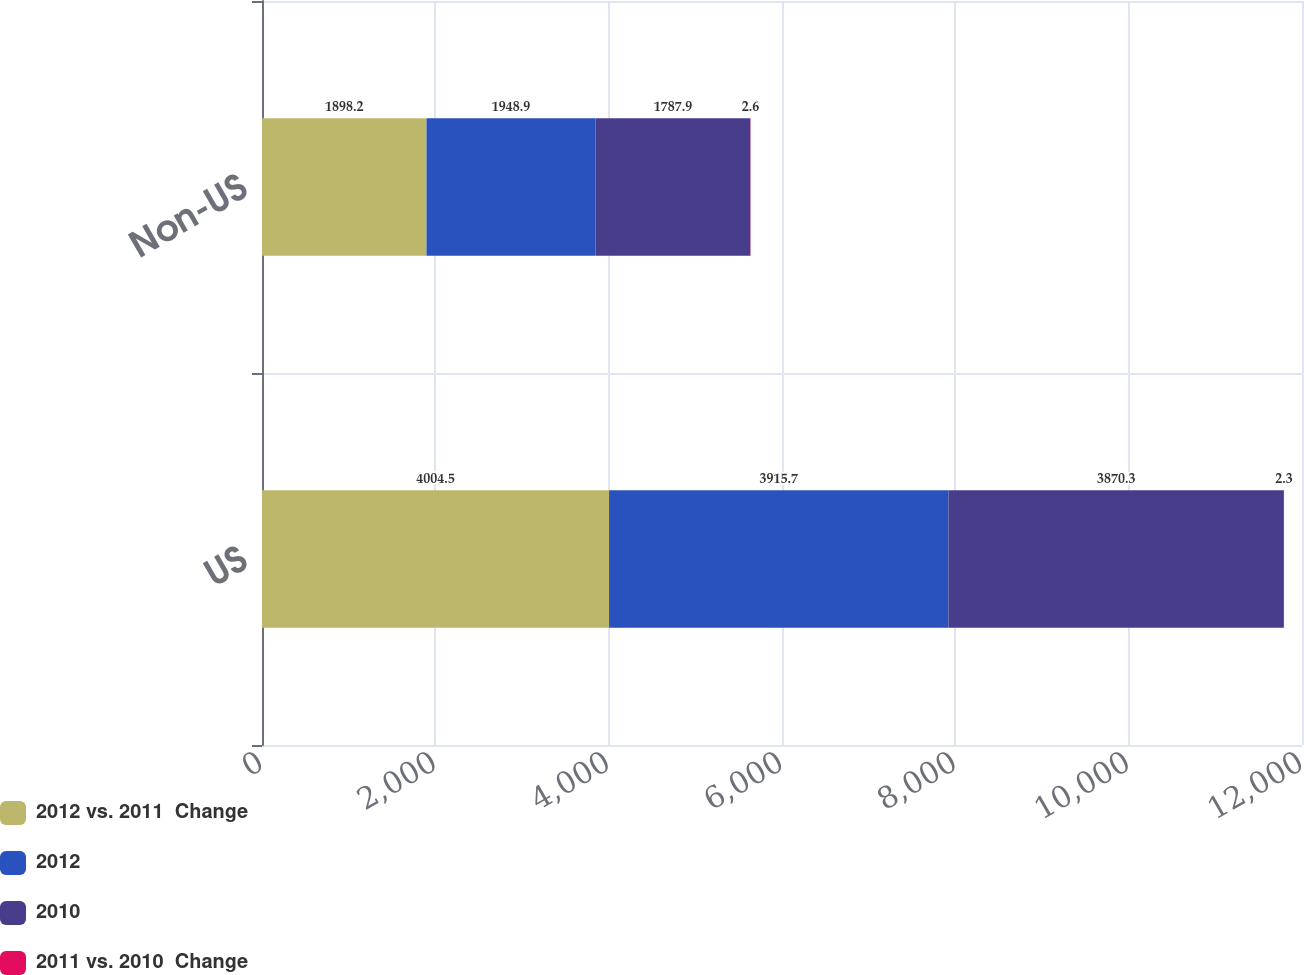Convert chart. <chart><loc_0><loc_0><loc_500><loc_500><stacked_bar_chart><ecel><fcel>US<fcel>Non-US<nl><fcel>2012 vs. 2011  Change<fcel>4004.5<fcel>1898.2<nl><fcel>2012<fcel>3915.7<fcel>1948.9<nl><fcel>2010<fcel>3870.3<fcel>1787.9<nl><fcel>2011 vs. 2010  Change<fcel>2.3<fcel>2.6<nl></chart> 